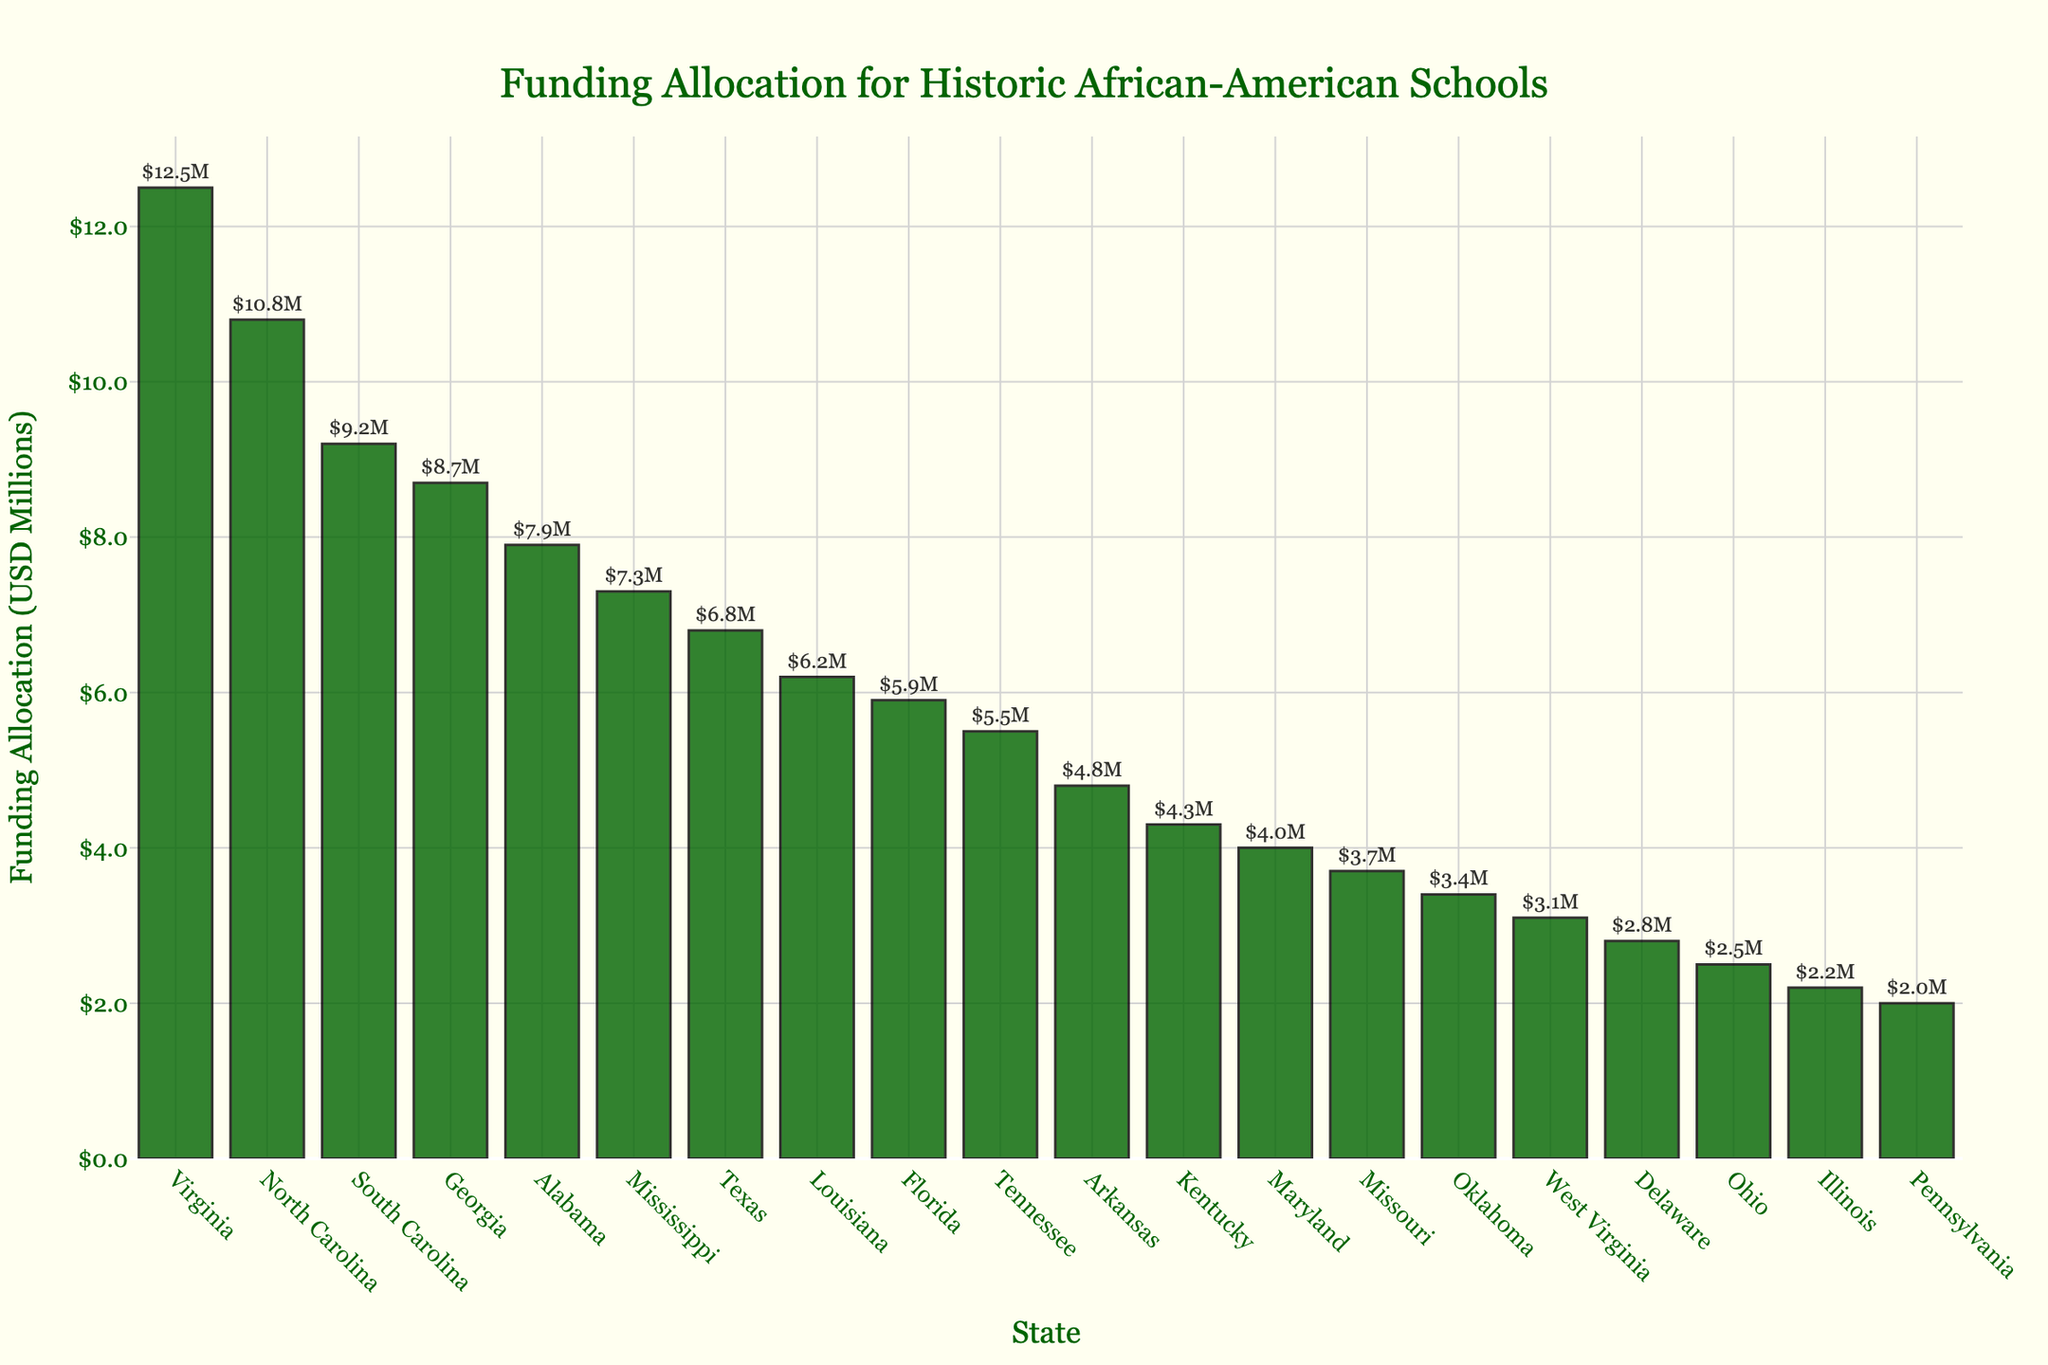What is the state with the highest funding allocation? The bar chart shows various states with different funding allocations. By looking at the tallest bar, we can see that Virginia has the highest funding allocation.
Answer: Virginia Which state has a higher funding allocation, Mississippi or Alabama? Comparing the heights of the bars for Mississippi and Alabama, Alabama's bar is taller than Mississippi's.
Answer: Alabama What is the total funding allocation for Georgia and Florida combined? By looking at the funding allocations for Georgia (8.7M) and Florida (5.9M), sum them up: 8.7 + 5.9 = 14.6M.
Answer: 14.6M Which states have funding allocations greater than 10 million? States with bars taller than the 10 million mark are Virginia (12.5M) and North Carolina (10.8M).
Answer: Virginia, North Carolina What is the difference in funding allocation between Texas and Maryland? The funding allocation for Texas is 6.8M, and for Maryland, it is 4.0M. The difference is 6.8 - 4.0 = 2.8M.
Answer: 2.8M What's the average funding allocation for the top 5 states? The top 5 states by funding are Virginia (12.5M), North Carolina (10.8M), South Carolina (9.2M), Georgia (8.7M), and Alabama (7.9M). The sum of these values is 49.1M. The average is 49.1 / 5 = 9.82M.
Answer: 9.82M Which state is positioned exactly in the middle when sorting by funding allocation? When sorting the states by funding allocation in descending order, Mississippi (7.3M) is in the middle.
Answer: Mississippi Are there more states with funding allocations below 5 million or above 5 million? By counting the bars, there are 4 states with allocations below 5 million (Delaware, Ohio, Illinois, Pennsylvania) and 16 states above 5 million.
Answer: More states above 5 million What's the range of the funding allocations shown in the chart? The range is the difference between the highest and lowest funding allocations. The highest allocation is Virginia (12.5M) and the lowest is Pennsylvania (2.0M). Thus, the range is 12.5 - 2.0 = 10.5M.
Answer: 10.5M 